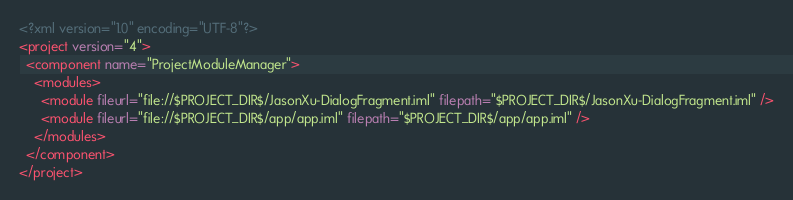Convert code to text. <code><loc_0><loc_0><loc_500><loc_500><_XML_><?xml version="1.0" encoding="UTF-8"?>
<project version="4">
  <component name="ProjectModuleManager">
    <modules>
      <module fileurl="file://$PROJECT_DIR$/JasonXu-DialogFragment.iml" filepath="$PROJECT_DIR$/JasonXu-DialogFragment.iml" />
      <module fileurl="file://$PROJECT_DIR$/app/app.iml" filepath="$PROJECT_DIR$/app/app.iml" />
    </modules>
  </component>
</project></code> 